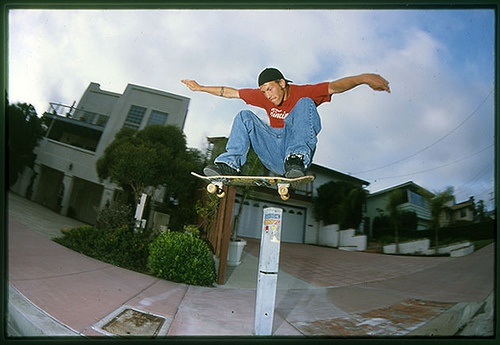Describe the objects in this image and their specific colors. I can see people in black, gray, and brown tones and skateboard in black, gray, darkgreen, and ivory tones in this image. 